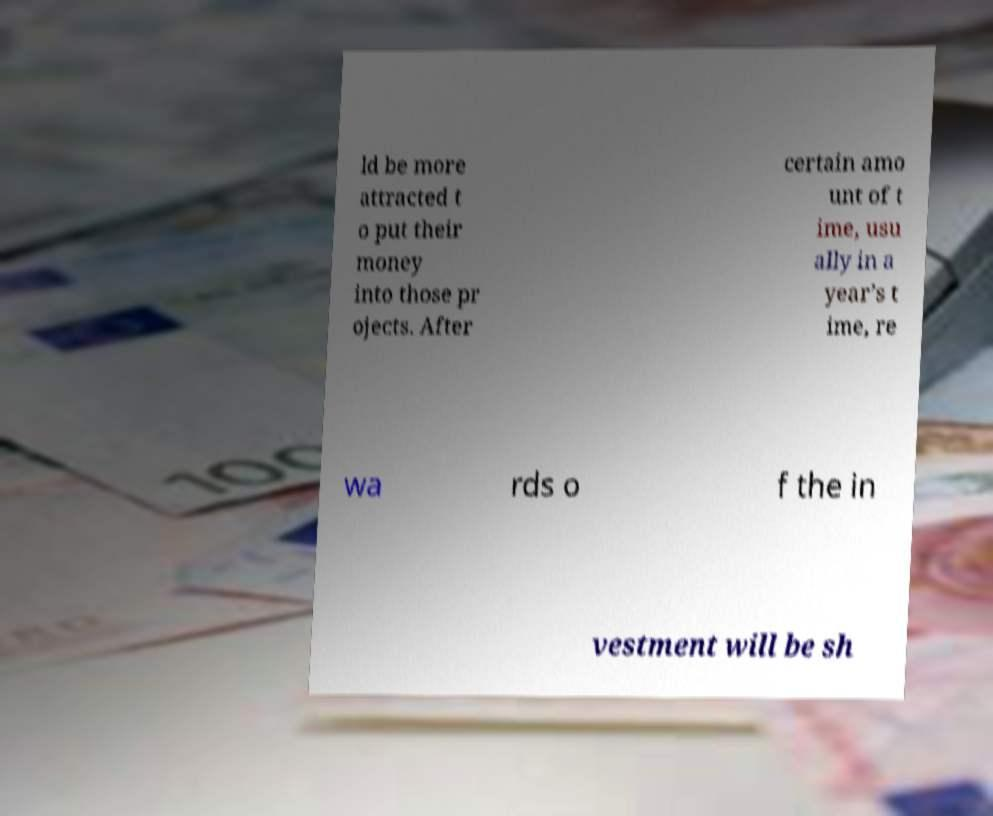Could you extract and type out the text from this image? ld be more attracted t o put their money into those pr ojects. After certain amo unt of t ime, usu ally in a year’s t ime, re wa rds o f the in vestment will be sh 